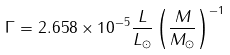<formula> <loc_0><loc_0><loc_500><loc_500>\Gamma = 2 . 6 5 8 \times 1 0 ^ { - 5 } \frac { L } { L _ { \odot } } \left ( \frac { M } { M _ { \odot } } \right ) ^ { - 1 }</formula> 